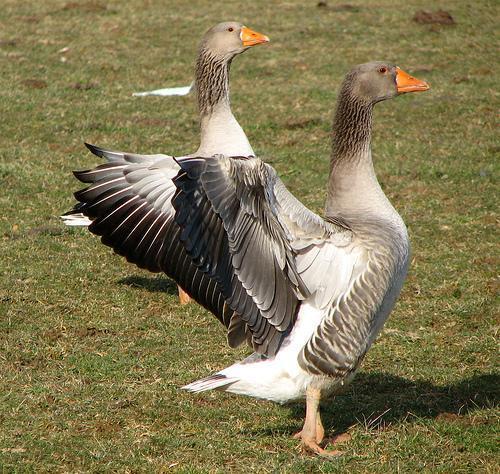How many birds are there?
Give a very brief answer. 2. How many different kinds of animals are in this picture?
Give a very brief answer. 1. How many chairs don't have a dog on them?
Give a very brief answer. 0. 